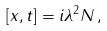Convert formula to latex. <formula><loc_0><loc_0><loc_500><loc_500>[ x , t ] = i \lambda ^ { 2 } N \, ,</formula> 